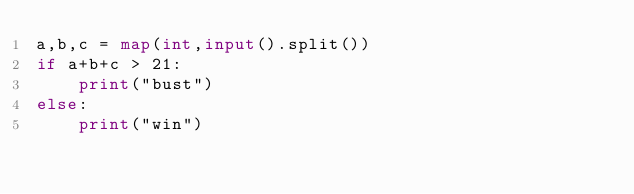<code> <loc_0><loc_0><loc_500><loc_500><_Python_>a,b,c = map(int,input().split())
if a+b+c > 21:
    print("bust")
else:
    print("win")</code> 